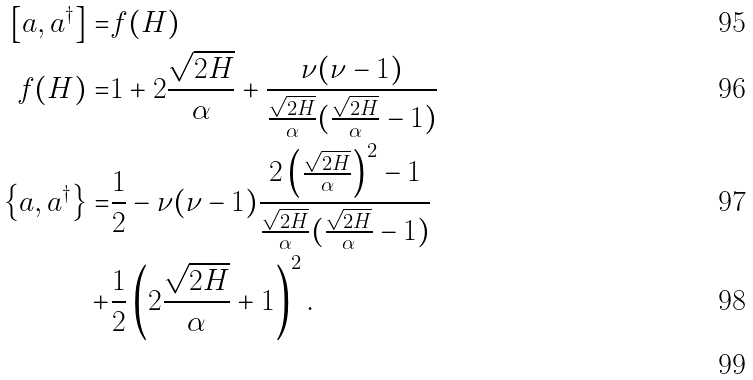Convert formula to latex. <formula><loc_0><loc_0><loc_500><loc_500>\left [ a , a ^ { \dagger } \right ] = & f ( H ) \\ f ( H ) = & 1 + 2 \frac { \sqrt { 2 H } } { \alpha } + \frac { \nu ( \nu - 1 ) } { \frac { \sqrt { 2 H } } { \alpha } ( \frac { \sqrt { 2 H } } { \alpha } - 1 ) } \\ \left \{ a , a ^ { \dagger } \right \} = & \frac { 1 } { 2 } - \nu ( \nu - 1 ) \frac { 2 \left ( \frac { \sqrt { 2 H } } { \alpha } \right ) ^ { 2 } - 1 } { \frac { \sqrt { 2 H } } { \alpha } ( \frac { \sqrt { 2 H } } { \alpha } - 1 ) } \\ + & \frac { 1 } { 2 } \left ( 2 \frac { \sqrt { 2 H } } { \alpha } + 1 \right ) ^ { 2 } . \\</formula> 